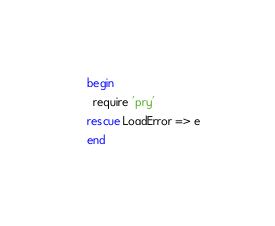<code> <loc_0><loc_0><loc_500><loc_500><_Ruby_>begin
  require 'pry'
rescue LoadError => e
end
</code> 